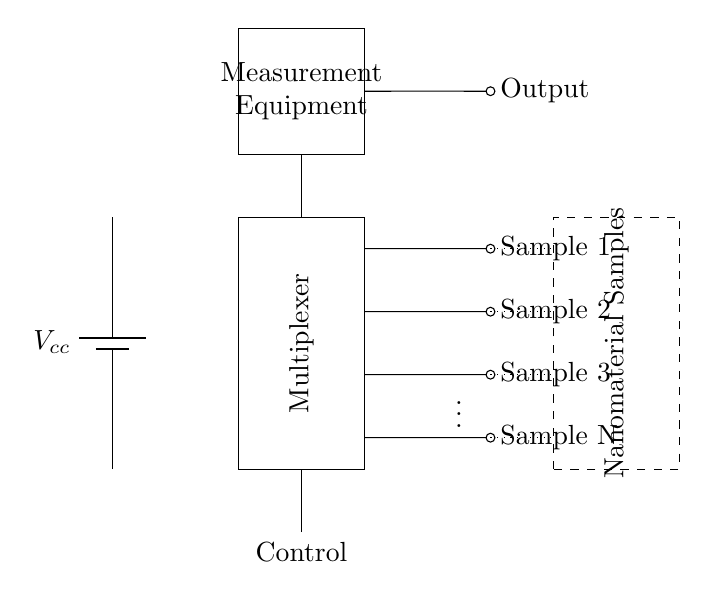What is the main component used to select multiple samples? The main component used to select multiple samples is the multiplexer, which allows for the connection of multiple input signals to a single output based on control inputs.
Answer: multiplexer What type of signals can be connected to the multiplexer? The signals connected to the multiplexer are the outputs from various nanomaterial samples, indicated by the dashed rectangle labeled "Nanomaterial Samples," each labeled as Sample 1, Sample 2, etc.
Answer: nanomaterial samples How many samples can the multiplexed circuit test simultaneously? The circuit is designed to test multiple samples in parallel, as indicated by the presence of multiple sample connections labeled from Sample 1 to Sample N, which suggests that it can handle a variable number of samples based on configuration.
Answer: N What is the purpose of the control line in this circuit? The control line serves the purpose of selecting which sample to read from the multiplexer at any given time, enabling the shift between different inputs based on the control signals applied.
Answer: selection What is the output of the measurement equipment? The output of the measurement equipment is the result of the quality control analysis performed on the selected nanomaterial sample, indicated in the diagram by the labeled output connection on the right side, where the output is taken from the measurement device.
Answer: output How does measurement equipment connect to the multiplexer? The measurement equipment connects to the multiplexer through a single output line that routes the chosen sample signal from the multiplexer to the measurement device for analysis.
Answer: single output line 